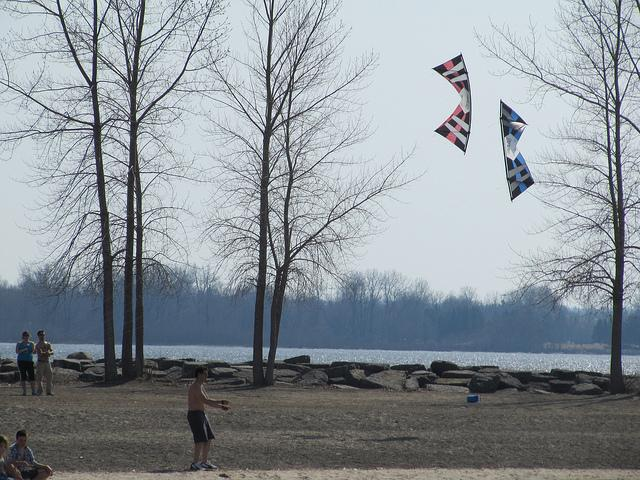What are the kites in most danger of getting stuck in?

Choices:
A) sand
B) trees
C) water
D) rocks trees 